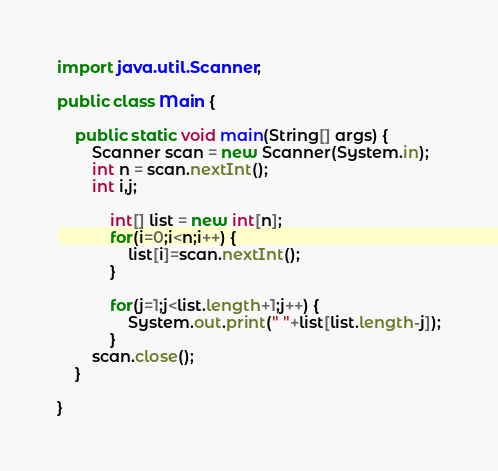<code> <loc_0><loc_0><loc_500><loc_500><_Java_>import java.util.Scanner;

public class Main {

	public static void main(String[] args) {
		Scanner scan = new Scanner(System.in);
		int n = scan.nextInt();
		int i,j;

			int[] list = new int[n];
			for(i=0;i<n;i++) {
				list[i]=scan.nextInt();
			}

			for(j=1;j<list.length+1;j++) {
				System.out.print(" "+list[list.length-j]);
			}
		scan.close();
	}

}

</code> 